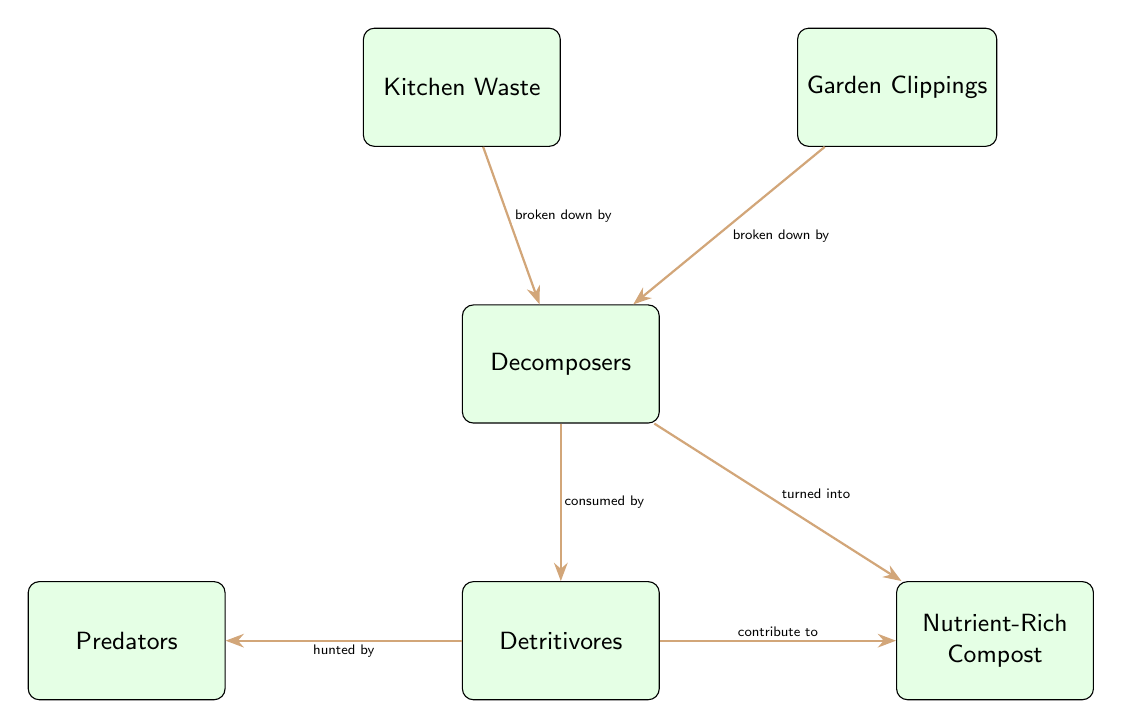What are the two inputs in the composting process? The inputs shown in the diagram are Kitchen Waste and Garden Clippings, which are represented as separate nodes that feed into the decomposition process.
Answer: Kitchen Waste, Garden Clippings Which organisms are categorized as decomposers in the process? The diagram specifically labels the node "Decomposers" that represents the organisms responsible for breaking down the kitchen waste and garden clippings.
Answer: Decomposers How many types of organisms are involved in the composting process? There are three types of organisms represented in the diagram: decomposers, detritivores, and predators, making a total of three types involved.
Answer: 3 What product is created after the decomposers break down the waste? After the decomposers work on the kitchen waste and garden clippings, they turn that material into nutrient-rich compost, as indicated by the corresponding node in the diagram.
Answer: Nutrient-Rich Compost Which type of organisms consume the decomposers? The detritivores are the organisms that are shown to consume the decomposers in the diagram. This is indicated by the directed arrow labeled "consumed by."
Answer: Detritivores How are predators related to detritivores? Predators are shown in the diagram to hunt the detritivores, which is indicated by the arrow labeled "hunted by," demonstrating the food chain relationship between these two types of organisms.
Answer: Hunted by What is the flow direction from kitchen waste to compost? The diagram illustrates that kitchen waste is broken down by decomposers, which then contributes to the formation of nutrient-rich compost, showing a clear flow path from kitchen waste to compost.
Answer: Kitchen Waste → Decomposers → Nutrient-Rich Compost Which node is directly influenced by detritivores? The node "Nutrient-Rich Compost" is directly influenced by detritivores, as indicated by the arrow labeled "contribute to," indicating their role in enriching the compost.
Answer: Nutrient-Rich Compost What is the relationship between garden clippings and decomposers? Garden clippings are broken down by decomposers, as denoted by the arrow labeled "broken down by," this shows the direct relationship between these two elements in the diagram.
Answer: Broken down by 